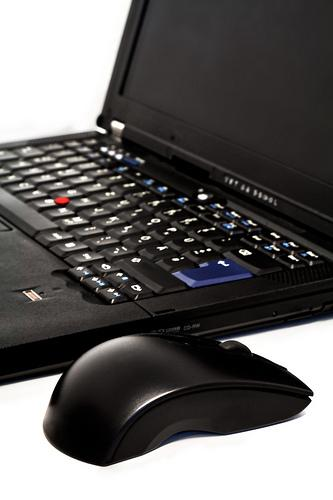Count the number of keys that are distinctly mentioned on the keyboard. There are 10 distinctly mentioned keys on the keyboard. What is the color of the table in the image? The table is white in color. Identify the color and type of computer device placed next to the laptop. There is a black wireless mouse placed beside the laptop. Perform a sentiment analysis on the image. What emotion does it evoke? The image evokes a sense of technological efficiency and productivity. How many objects are said to have a red color in their description? There are three objects with red color in their description. What color is the Enter key on the keyboard? The Enter key on the keyboard is dark blue. Is the laptop screen on or off? Off, and it is black. What text is displayed in white writing on the laptop screen? Company name Decode and describe the configuration of the laptop keyboard. The laptop keyboard has an alphabet and numeric keys, along with a blue enter key, red pointing stick, and black spacebar. Describe the color and shape of the mouse beside the laptop. The mouse is black and has an oval shape. Describe the position of the light under the mouse. The light is positioned at the bottom of the mouse. Which type of key is found on the keyboard apart from alphabetical keys? Numeric and symbolic keys Is there a key on the keyboard with the alphabet 'A'? Yes What is the color of the wireless mouse? Black Create a description of the image including the color of the hinges on the laptop. The image features a black laptop with silver hinges, a blue enter key, a red pointing stick, and a black mouse beside it. Identify the main activity occurring in the image. A laptop with a keyboard and mouse. Which color is the button on the keyboard? Blue The yellow headphones are connected to the laptop's side, and the brand logo is visible on the outer surface of the headphones. Check it out. There is no mention of yellow headphones or any connection to the laptop in the given information. This instruction is misleading because it introduces a non-existent object with declarative sentences to suggest the reader search for headphones. Can you find the green USB stick placed beside the black mouse? It's right next to the edge of the table. There is no mention of a green USB stick or its position in the given information. This instruction is misleading because it introduces a non-existent object and includes an interrogative sentence. Notice the orange coffee mug placed on the white table close to the mouse, which has a slight steam coming out of it. There is no mention of an orange coffee mug or any steam coming out of it in the given information. This instruction is misleading because it introduces a non-existent object with declarative sentences, incorporating sensory elements like steam. What is the distinguishing feature on the side of the laptop? A CDRW drive What event is happening on the screen of the laptop? Displaying the company name. What type of keyboard key is dark blue? Enter key Describe the relationship between the laptop screen and the writing on it. The laptop screen displays the company name in white writing. Find the brown framed photograph standing near the laptop, which has a picture of a landscape with mountains and trees. There is no mention of a brown framed photograph or its position near the laptop in the given information. This instruction is misleading because it introduces a non-existent object with declarative sentences and adds visual details that cannot be found in the image. Spot the purple sticker on the laptop's lid, which has a cat cartoon design. Where is it placed? There is no mention of a purple sticker or any cat design on the laptop in the information. This instruction is misleading because it introduces a non-existent object with an interrogative sentence to make the reader question the sticker's location. What is the main function of the red key on the keyboard? Cursor control Create a dynamic description of the laptop and the mouse in the image. A black laptop with a turned-off screen rests alongside a sleek black wireless mouse, creating a harmonious and stylish setup. What expression is shown on the cursor control button? None, it is a red button. Can you locate the gray notebook beside the black laptop? The pages it lays open display some handwritten notes. There is no mention of a gray notebook or its position near the laptop in the given information. This instruction is misleading because it introduces a non-existent object and combines both declarative and interrogative sentences to create the illusion of detail. Select the keywords that describe the color of the laptop monitor. Answer:  